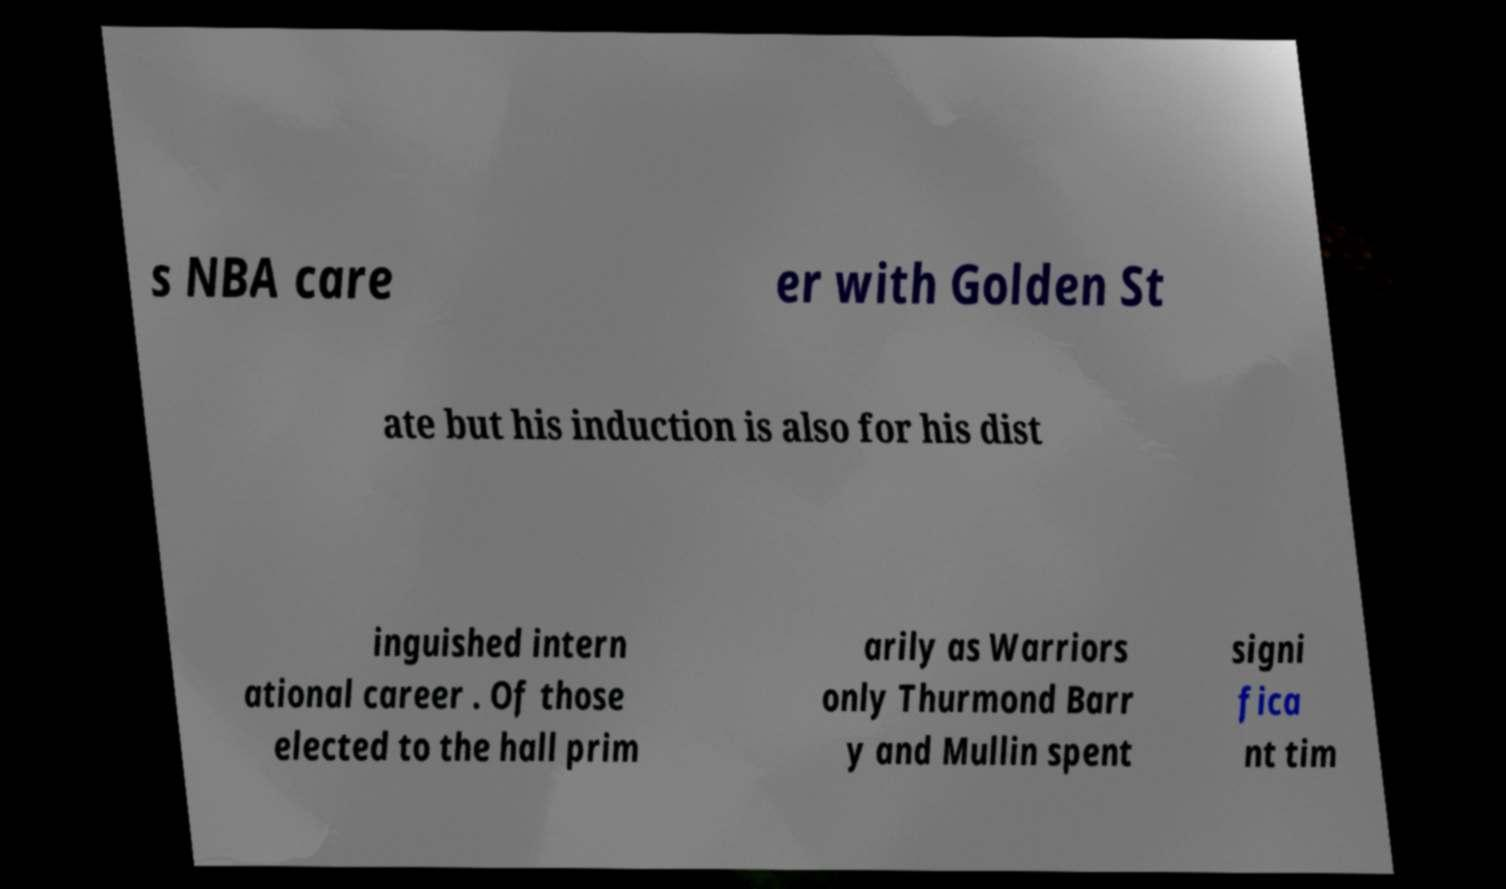There's text embedded in this image that I need extracted. Can you transcribe it verbatim? s NBA care er with Golden St ate but his induction is also for his dist inguished intern ational career . Of those elected to the hall prim arily as Warriors only Thurmond Barr y and Mullin spent signi fica nt tim 